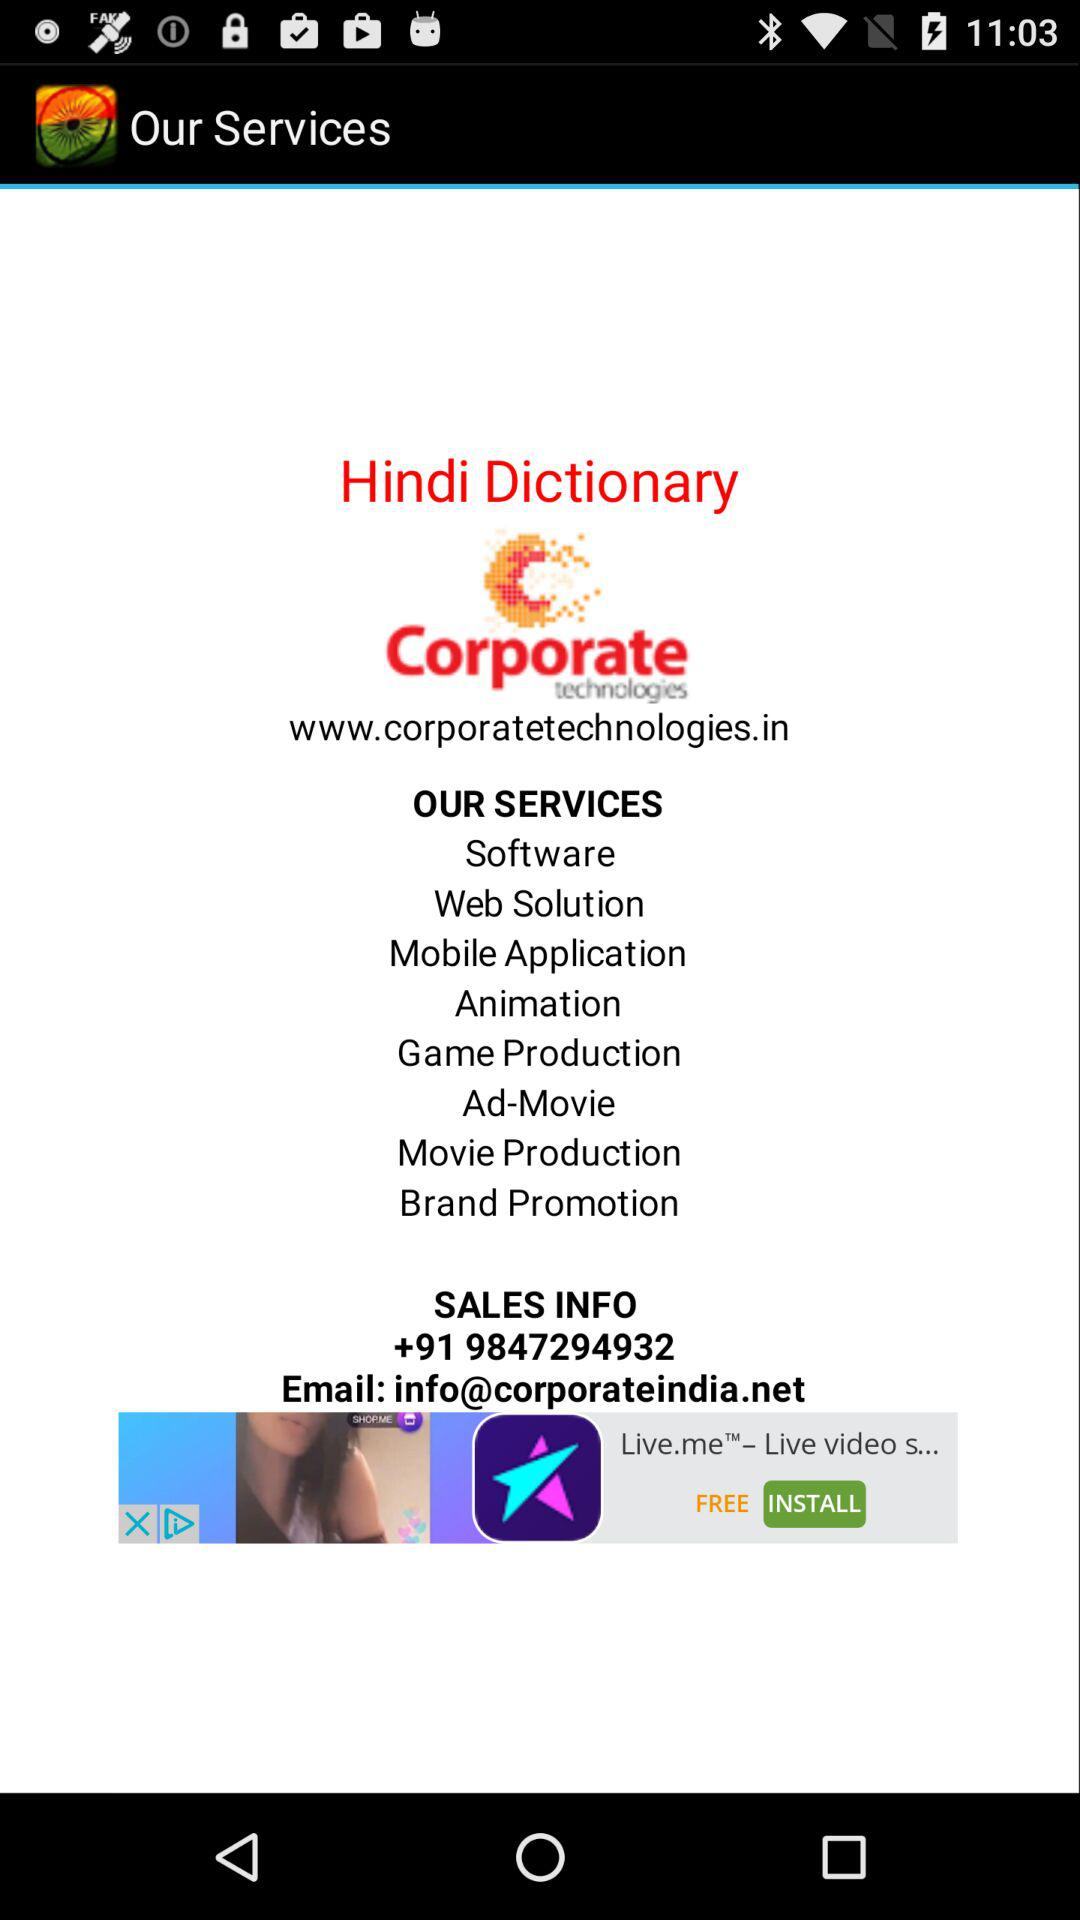What is the email ID for Corporate Technologies? The email ID for Corporate Technologies is info@corporateindia.net. 